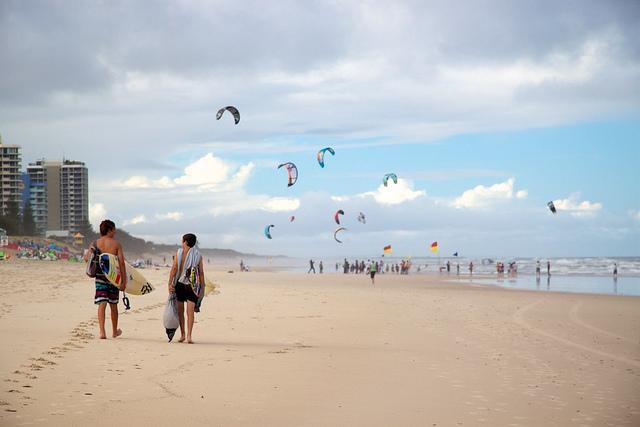Where is this picture taken?
Answer briefly. Beach. Are they on a mountain?
Give a very brief answer. No. What is flying?
Write a very short answer. Kites. Do these birds like to steal food from you?
Give a very brief answer. Yes. 